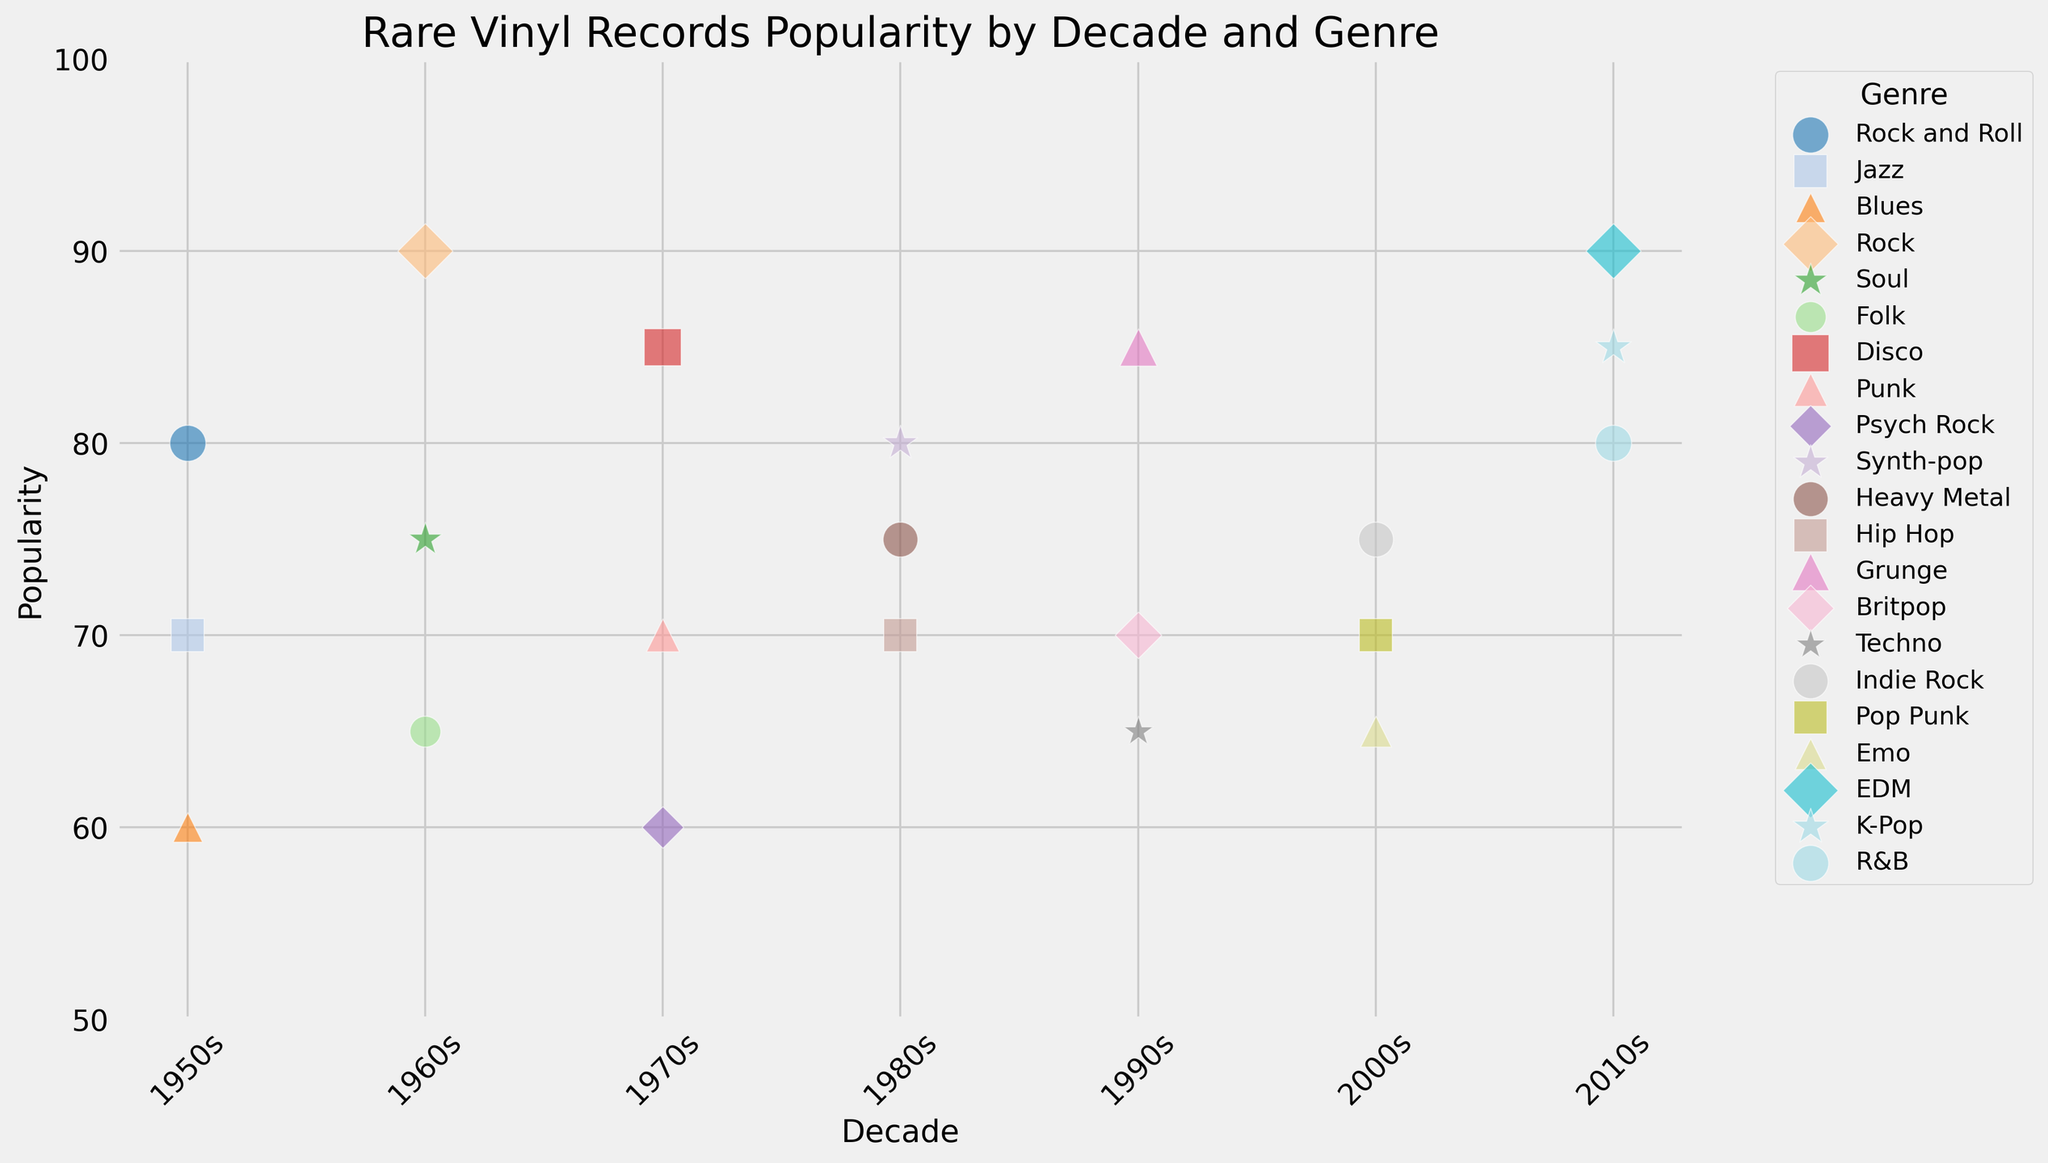What genre had the highest popularity in the 2010s? By checking the y-values for the genres in the 2010s, we see that EDM has the highest popularity at 90.
Answer: EDM Which decade had the most varied genres visually, based on different colors? Counting the number of different colors representing genres per decade, we see that the 2010s have three different genres, indicated by three different colors.
Answer: 2010s Between the 1960s and 1970s, which genre had the highest popularity and what was its value? By comparing the bubbles' y-values in both decades, we observe that the 1960s' Rock has the highest popularity of 90.
Answer: Rock, 90 Which two decades had genres with a bubble size of 25, and what are those genres? The bubbles with a size of 25 are Jazz in the 1950s, Punk in the 1970s, Hip Hop in the 1980s, Britpop in the 1990s, and Pop Punk in the 2000s. Counting the decades, it’s the 1950s, 1970s, 1980s, 1990s, and 2000s.
Answer: 1950s (Jazz), 1970s (Punk), 1980s (Hip Hop), 1990s (Britpop), 2000s (Pop Punk) In the 1990s, which genre has the smallest bubble size, indicating the rarity size of records? Analyzing the bubble sizes in the 1990s, Techno has the smallest bubble size of 22.
Answer: Techno How does the popularity of Synth-pop in the 1980s compare to Hip Hop in the same decade? Synth-pop has a popularity of 80, while Hip Hop’s popularity is 70, thus Synth-pop is more popular.
Answer: Synth-pop is more popular If you combine the popularity of Rock and Jazz in the 1950s, what would be their total popularity? Summing the popularity values for Rock and Roll (80) and Jazz (70) in the 1950s, we get 80 + 70 = 150.
Answer: 150 How many genres have a popularity value equal to or greater than 85 across all decades? Counting all genres with a popularity value of 85 or more: Rock (1960s), Disco (1970s), Grunge (1990s), EDM (2010s), K-Pop (2010s), we get five genres.
Answer: 5 What is the average popularity of genres in the 2000s? Summing the popularity values of genres in the 2000s (Indie Rock: 75, Pop Punk: 70, Emo: 65) and dividing by the number of genres, (75+70+65)/3 = 70.
Answer: 70 Which genre has a different marker shape in the 1970s? By inspecting the shapes of the bubbles in the 1970s, the one with a different shape has a star marker, representing Disco.
Answer: Disco 